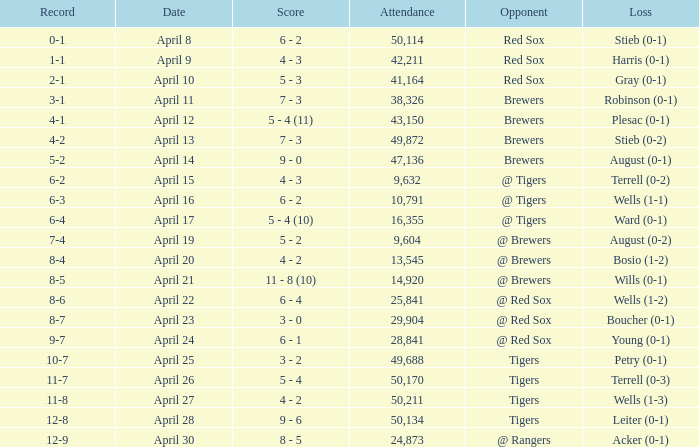Which opponent has a loss of wells (1-3)? Tigers. 